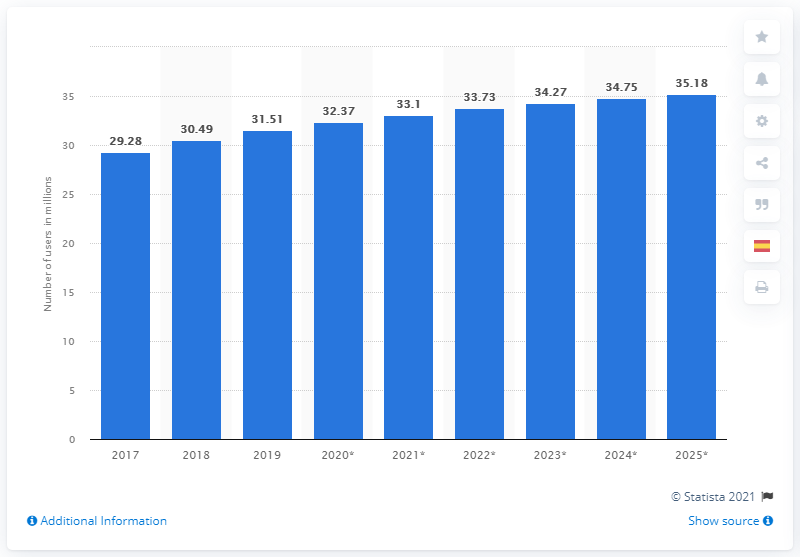Specify some key components in this picture. By 2025, it is projected that there will be approximately 35.18 million social network users in Argentina. In 2019, there were approximately 31.51 million social network users in Argentina. 